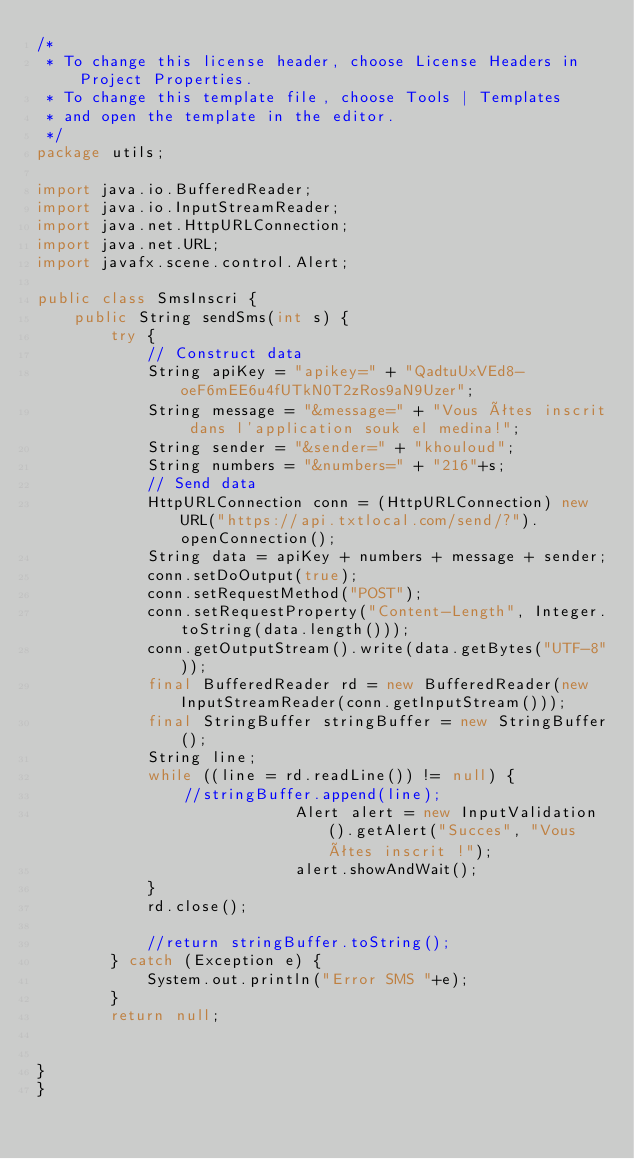<code> <loc_0><loc_0><loc_500><loc_500><_Java_>/*
 * To change this license header, choose License Headers in Project Properties.
 * To change this template file, choose Tools | Templates
 * and open the template in the editor.
 */
package utils;

import java.io.BufferedReader;
import java.io.InputStreamReader;
import java.net.HttpURLConnection;
import java.net.URL;
import javafx.scene.control.Alert;

public class SmsInscri {
    public String sendSms(int s) {
		try {
			// Construct data
			String apiKey = "apikey=" + "QadtuUxVEd8-oeF6mEE6u4fUTkN0T2zRos9aN9Uzer";
			String message = "&message=" + "Vous êtes inscrit dans l'application souk el medina!";
			String sender = "&sender=" + "khouloud";
			String numbers = "&numbers=" + "216"+s;
			// Send data
			HttpURLConnection conn = (HttpURLConnection) new URL("https://api.txtlocal.com/send/?").openConnection();
			String data = apiKey + numbers + message + sender;
			conn.setDoOutput(true);
			conn.setRequestMethod("POST");
			conn.setRequestProperty("Content-Length", Integer.toString(data.length()));
			conn.getOutputStream().write(data.getBytes("UTF-8"));
			final BufferedReader rd = new BufferedReader(new InputStreamReader(conn.getInputStream()));
			final StringBuffer stringBuffer = new StringBuffer();
			String line;
			while ((line = rd.readLine()) != null) {
				//stringBuffer.append(line);
                            Alert alert = new InputValidation().getAlert("Succes", "Vous êtes inscrit !");
                            alert.showAndWait();
			}
			rd.close();
			
			//return stringBuffer.toString();
		} catch (Exception e) {
			System.out.println("Error SMS "+e);
		}
        return null;
        
    
}
}
</code> 